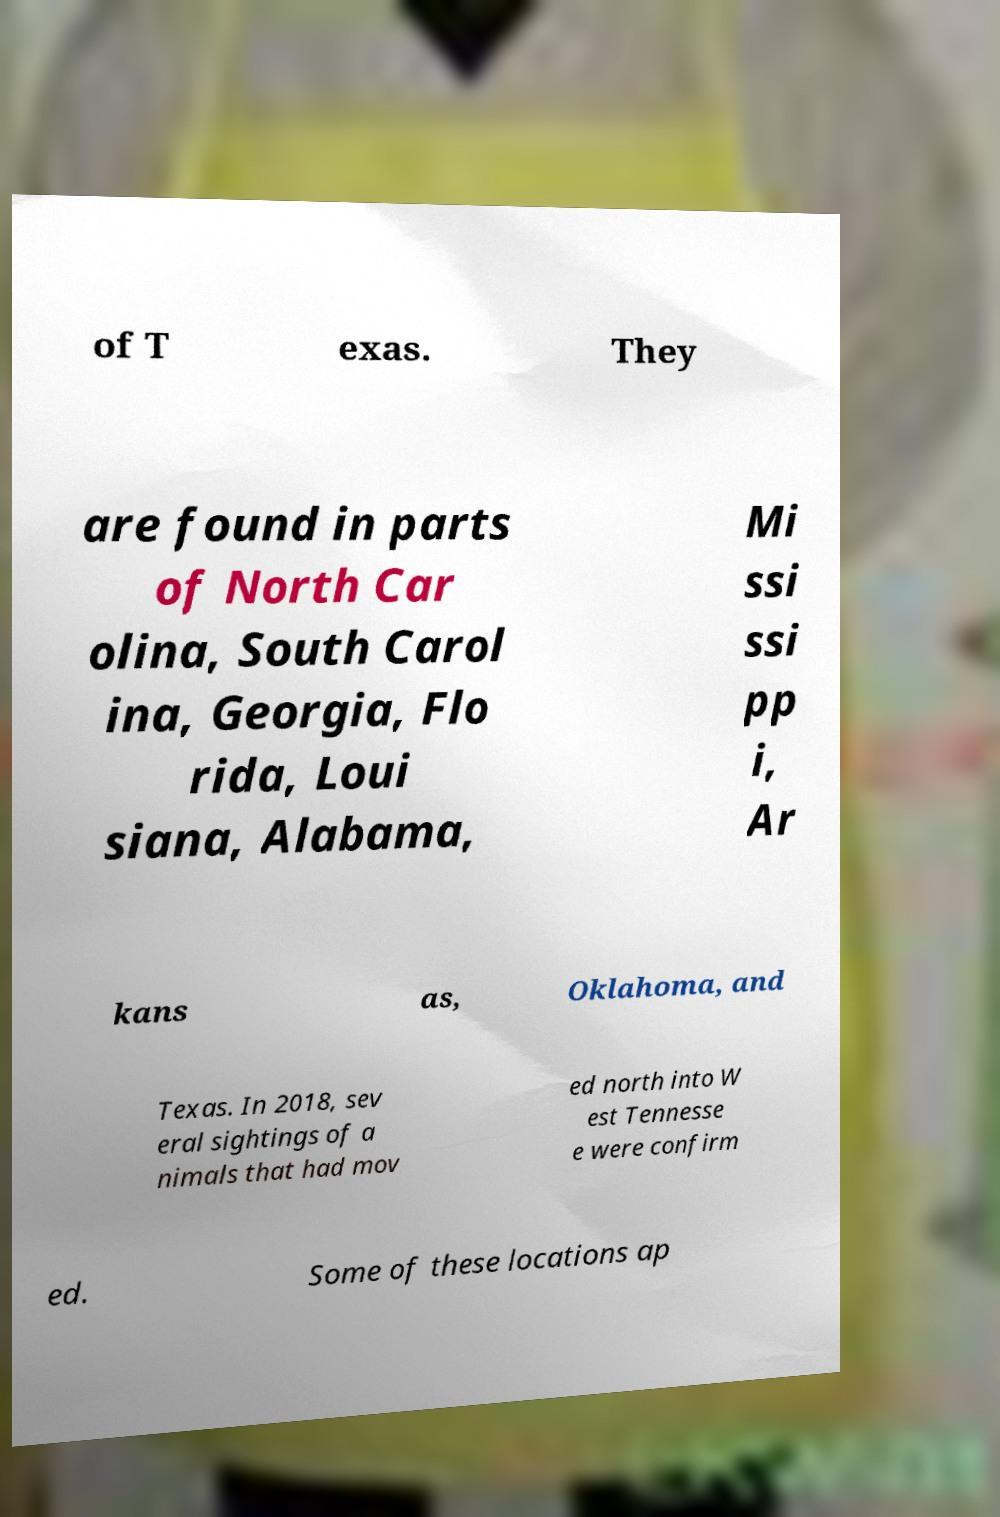Please read and relay the text visible in this image. What does it say? of T exas. They are found in parts of North Car olina, South Carol ina, Georgia, Flo rida, Loui siana, Alabama, Mi ssi ssi pp i, Ar kans as, Oklahoma, and Texas. In 2018, sev eral sightings of a nimals that had mov ed north into W est Tennesse e were confirm ed. Some of these locations ap 